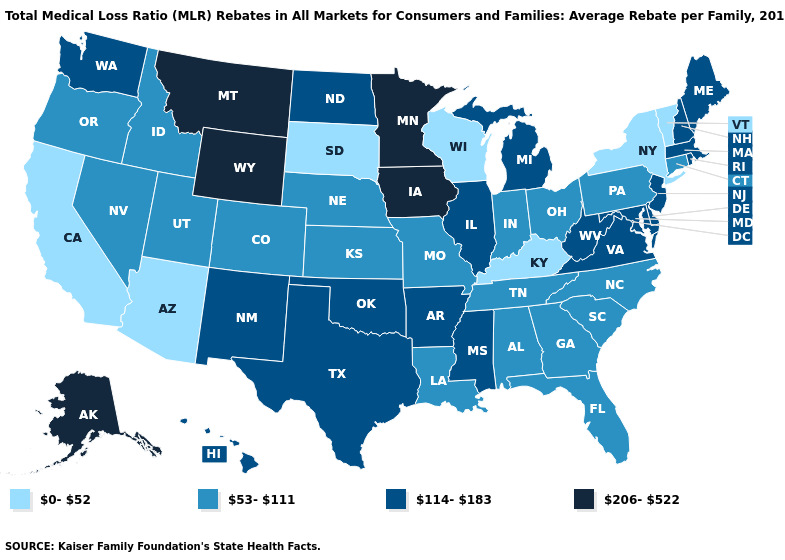What is the lowest value in the USA?
Be succinct. 0-52. Name the states that have a value in the range 53-111?
Be succinct. Alabama, Colorado, Connecticut, Florida, Georgia, Idaho, Indiana, Kansas, Louisiana, Missouri, Nebraska, Nevada, North Carolina, Ohio, Oregon, Pennsylvania, South Carolina, Tennessee, Utah. Which states hav the highest value in the West?
Be succinct. Alaska, Montana, Wyoming. Is the legend a continuous bar?
Concise answer only. No. What is the highest value in the South ?
Keep it brief. 114-183. What is the value of Washington?
Give a very brief answer. 114-183. What is the value of Rhode Island?
Be succinct. 114-183. What is the value of Rhode Island?
Quick response, please. 114-183. Does Tennessee have a higher value than Arizona?
Answer briefly. Yes. What is the lowest value in the Northeast?
Quick response, please. 0-52. What is the value of South Dakota?
Short answer required. 0-52. What is the lowest value in the West?
Write a very short answer. 0-52. Which states have the highest value in the USA?
Short answer required. Alaska, Iowa, Minnesota, Montana, Wyoming. Does Colorado have the highest value in the West?
Quick response, please. No. Name the states that have a value in the range 53-111?
Write a very short answer. Alabama, Colorado, Connecticut, Florida, Georgia, Idaho, Indiana, Kansas, Louisiana, Missouri, Nebraska, Nevada, North Carolina, Ohio, Oregon, Pennsylvania, South Carolina, Tennessee, Utah. 